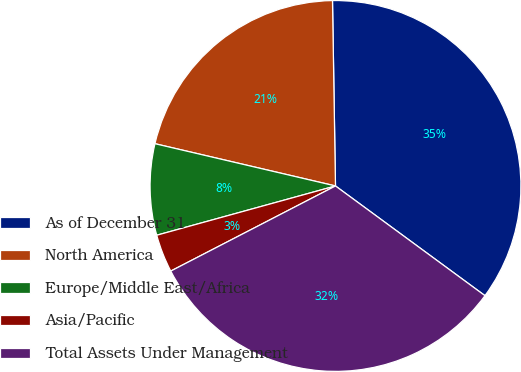<chart> <loc_0><loc_0><loc_500><loc_500><pie_chart><fcel>As of December 31<fcel>North America<fcel>Europe/Middle East/Africa<fcel>Asia/Pacific<fcel>Total Assets Under Management<nl><fcel>35.33%<fcel>21.08%<fcel>7.94%<fcel>3.31%<fcel>32.33%<nl></chart> 